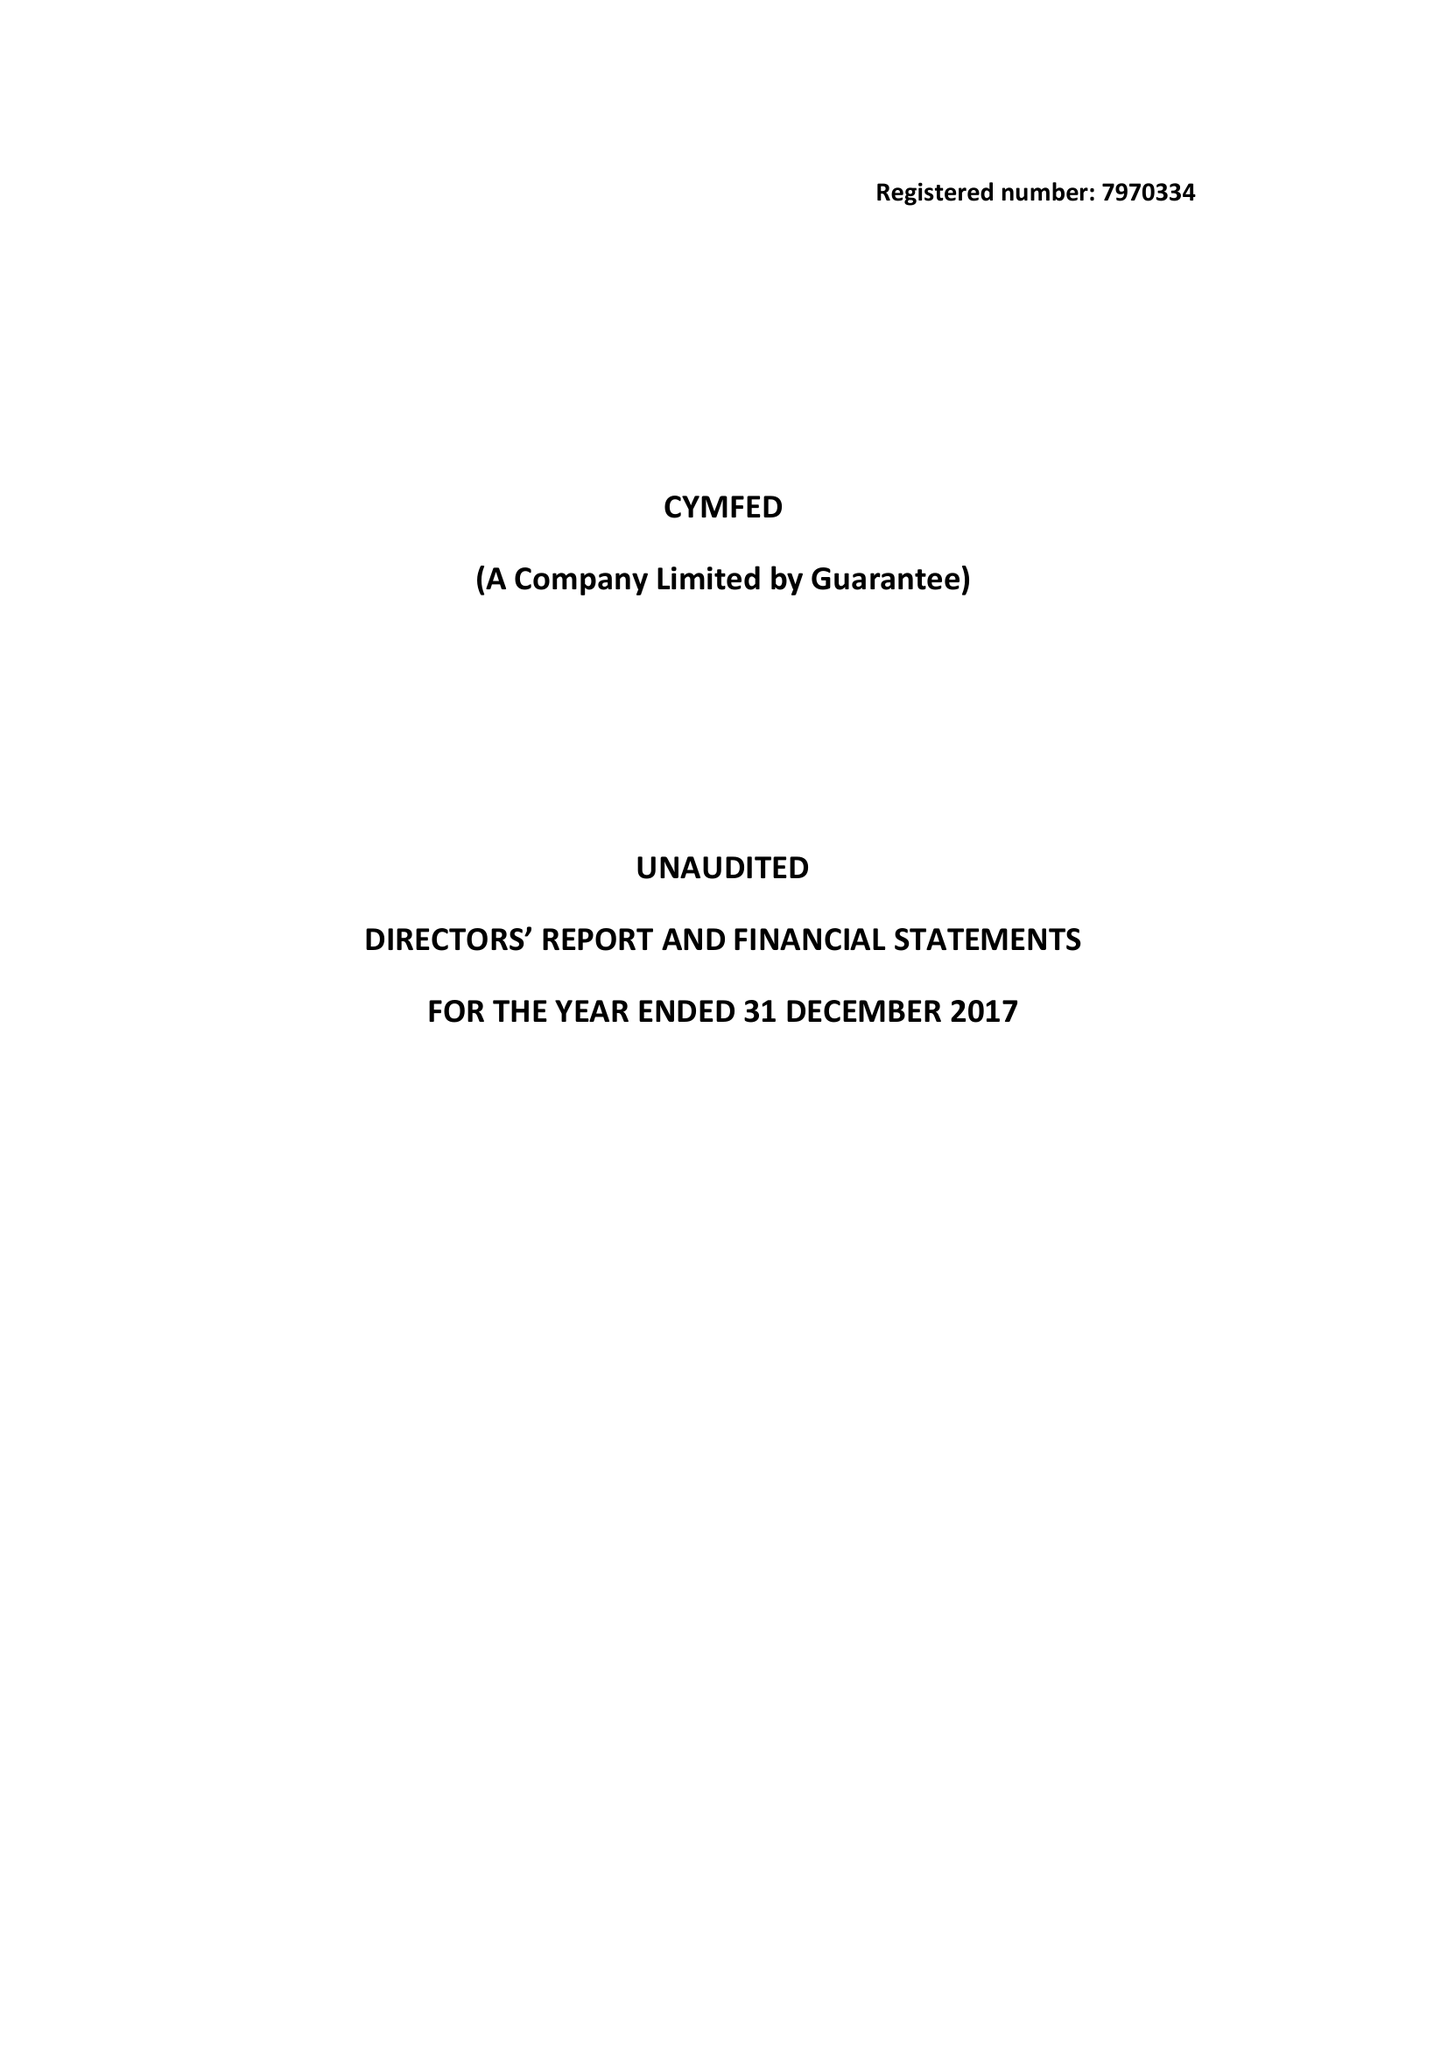What is the value for the address__post_town?
Answer the question using a single word or phrase. LONDON 